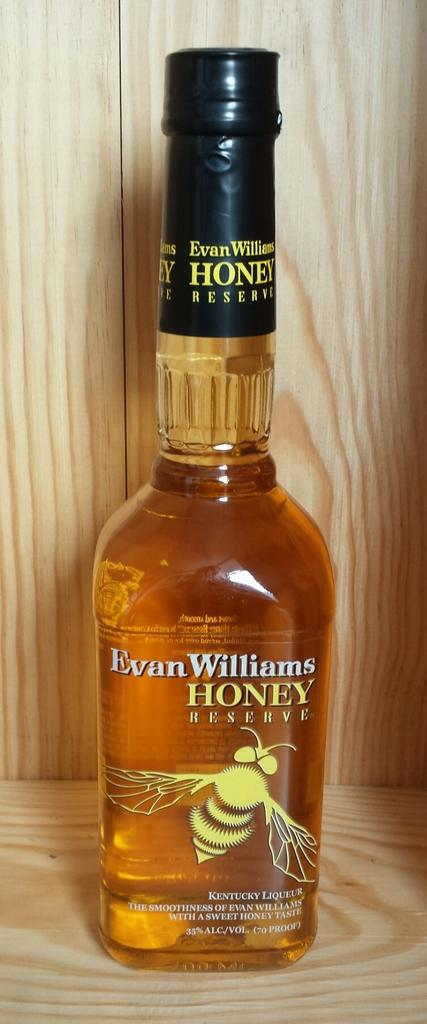Provide a one-sentence caption for the provided image. An unopened bottle of Evan Williams Honey Reserve whiskey. 